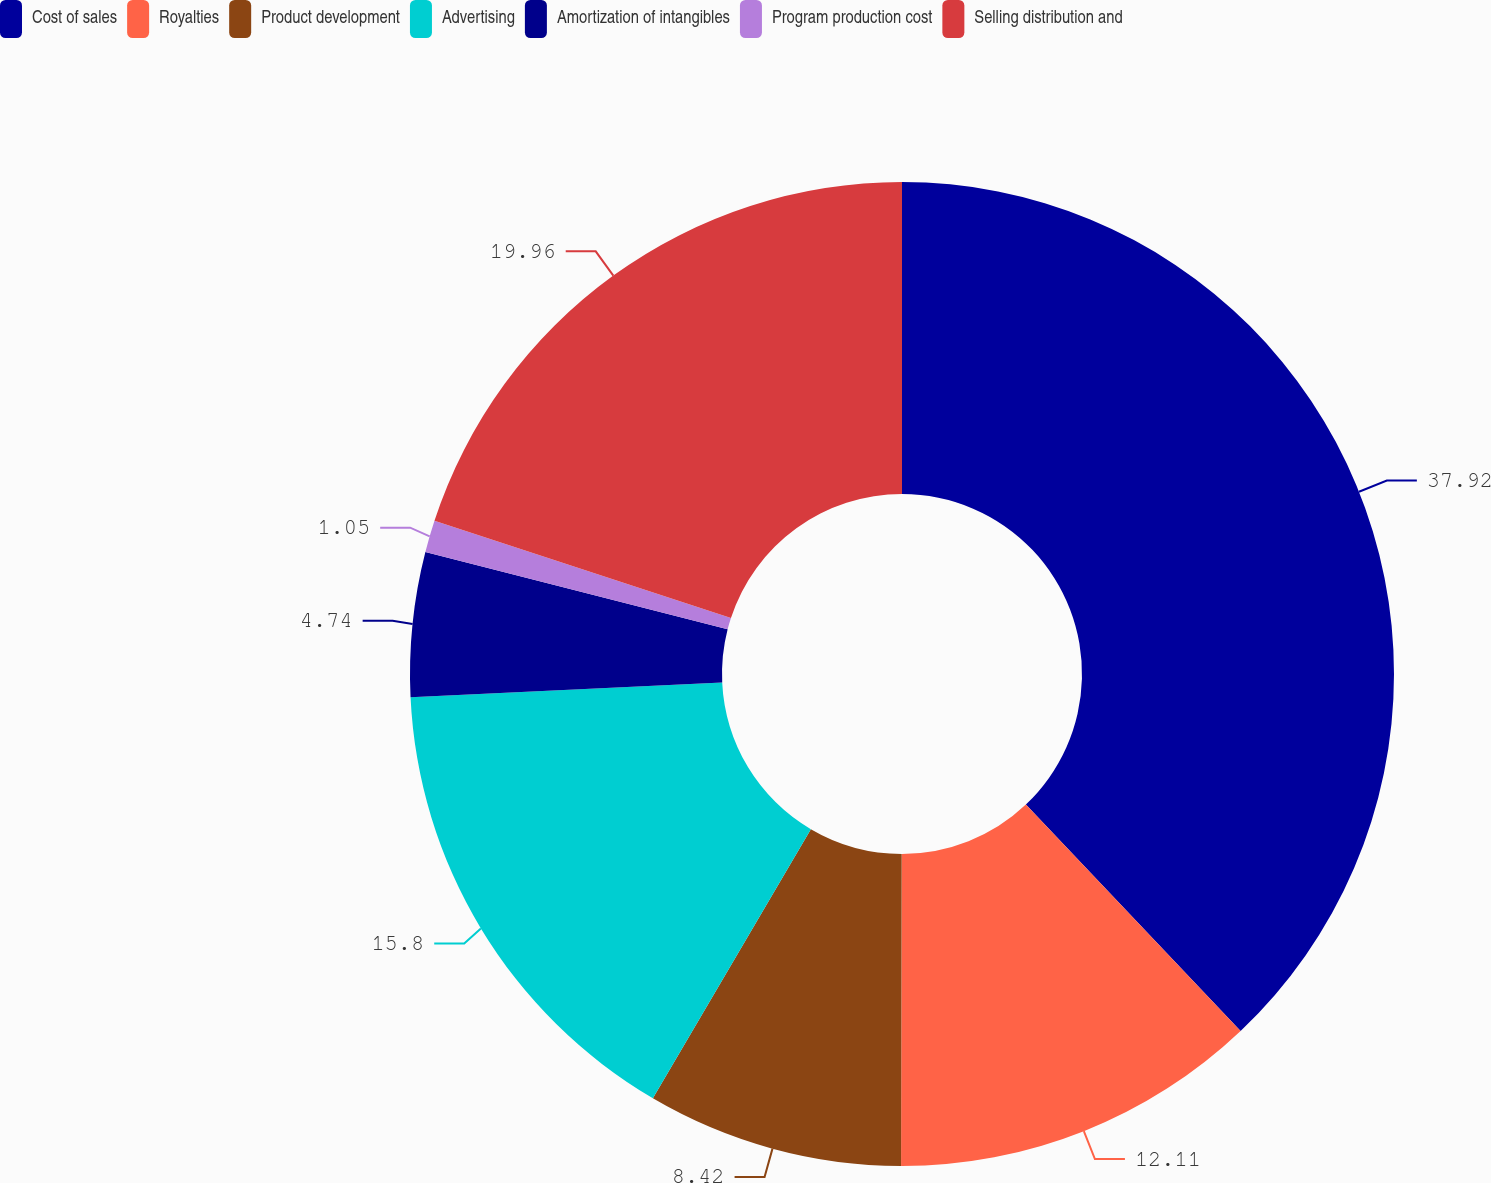Convert chart. <chart><loc_0><loc_0><loc_500><loc_500><pie_chart><fcel>Cost of sales<fcel>Royalties<fcel>Product development<fcel>Advertising<fcel>Amortization of intangibles<fcel>Program production cost<fcel>Selling distribution and<nl><fcel>37.92%<fcel>12.11%<fcel>8.42%<fcel>15.8%<fcel>4.74%<fcel>1.05%<fcel>19.96%<nl></chart> 